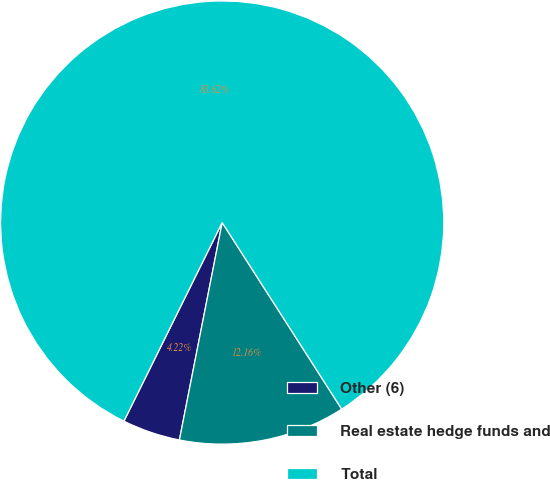<chart> <loc_0><loc_0><loc_500><loc_500><pie_chart><fcel>Other (6)<fcel>Real estate hedge funds and<fcel>Total<nl><fcel>4.22%<fcel>12.16%<fcel>83.62%<nl></chart> 